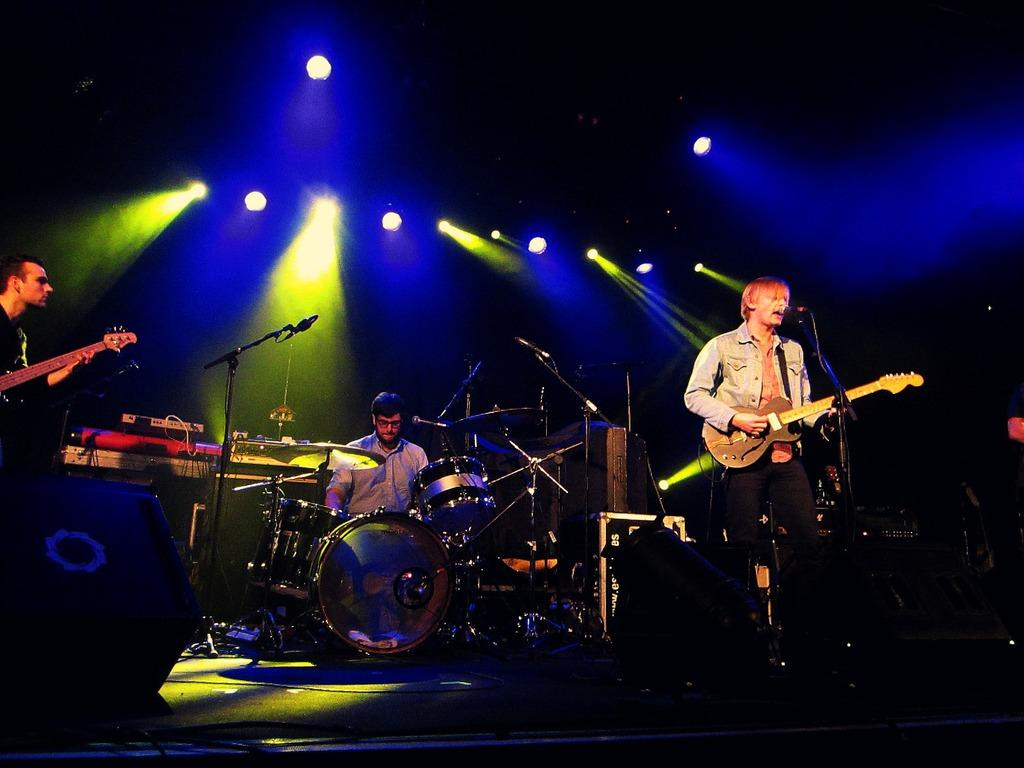How many people are in the image? There are three people in the image. What are the people doing in the image? The people are playing musical instruments. What types of musical instruments are being played? There are different musical instruments being played. Can you describe any other features in the image? There are lights on the roof in the image. How does the wave affect the people playing musical instruments in the image? There is no wave present in the image, so it does not affect the people playing musical instruments. 